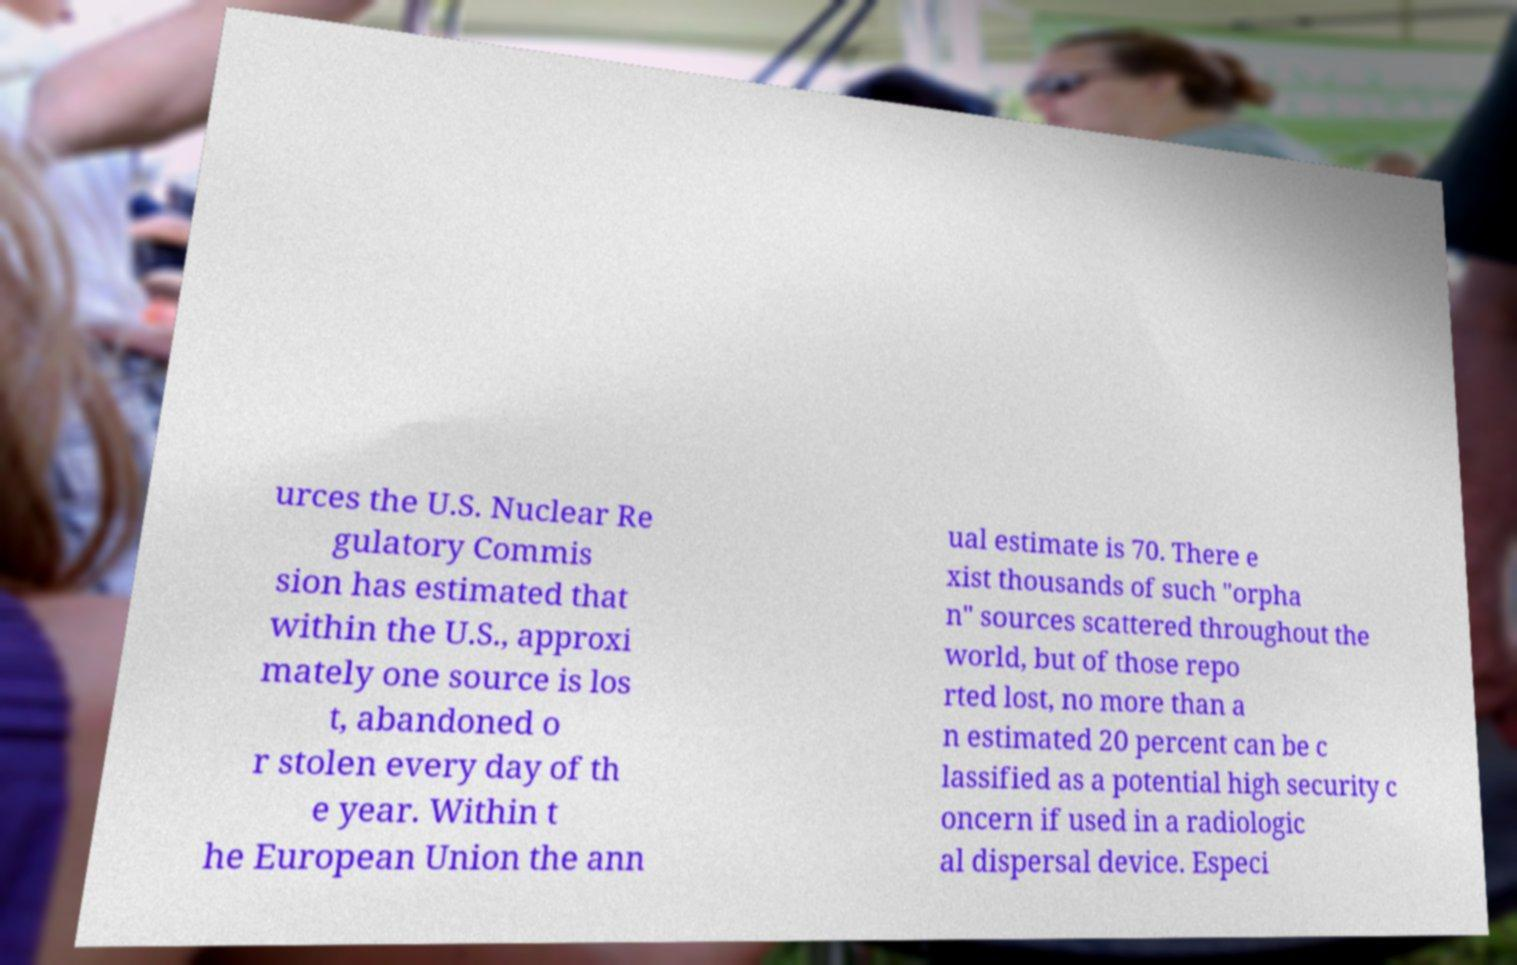Could you extract and type out the text from this image? urces the U.S. Nuclear Re gulatory Commis sion has estimated that within the U.S., approxi mately one source is los t, abandoned o r stolen every day of th e year. Within t he European Union the ann ual estimate is 70. There e xist thousands of such "orpha n" sources scattered throughout the world, but of those repo rted lost, no more than a n estimated 20 percent can be c lassified as a potential high security c oncern if used in a radiologic al dispersal device. Especi 